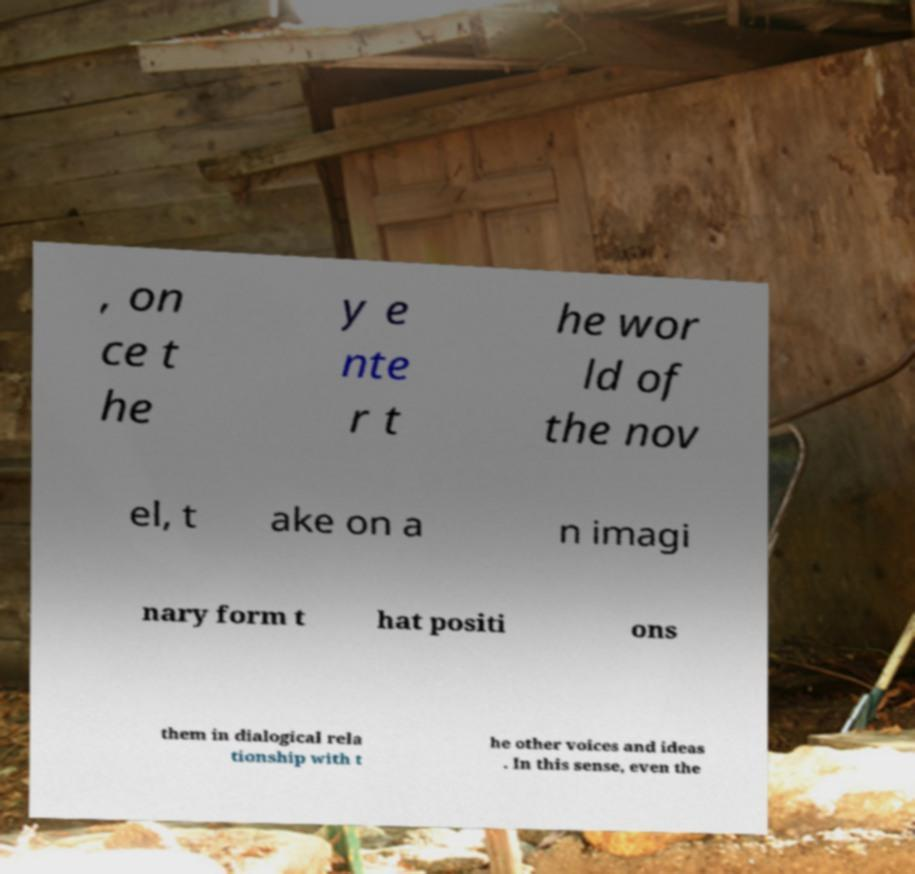Can you accurately transcribe the text from the provided image for me? , on ce t he y e nte r t he wor ld of the nov el, t ake on a n imagi nary form t hat positi ons them in dialogical rela tionship with t he other voices and ideas . In this sense, even the 